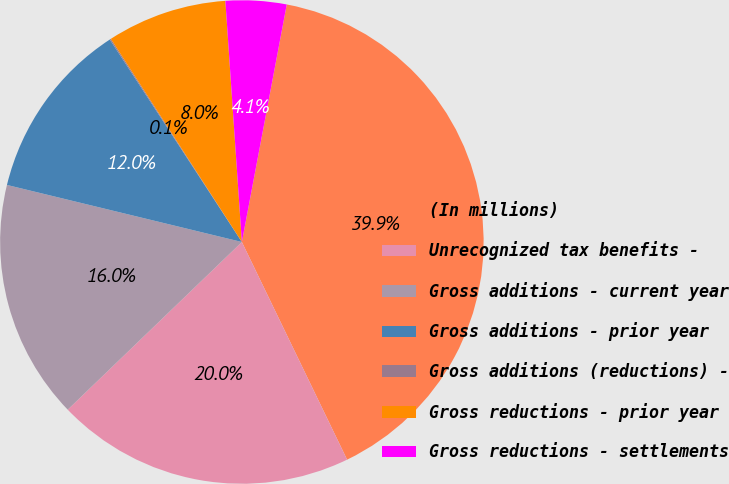<chart> <loc_0><loc_0><loc_500><loc_500><pie_chart><fcel>(In millions)<fcel>Unrecognized tax benefits -<fcel>Gross additions - current year<fcel>Gross additions - prior year<fcel>Gross additions (reductions) -<fcel>Gross reductions - prior year<fcel>Gross reductions - settlements<nl><fcel>39.86%<fcel>19.97%<fcel>15.99%<fcel>12.01%<fcel>0.08%<fcel>8.03%<fcel>4.06%<nl></chart> 